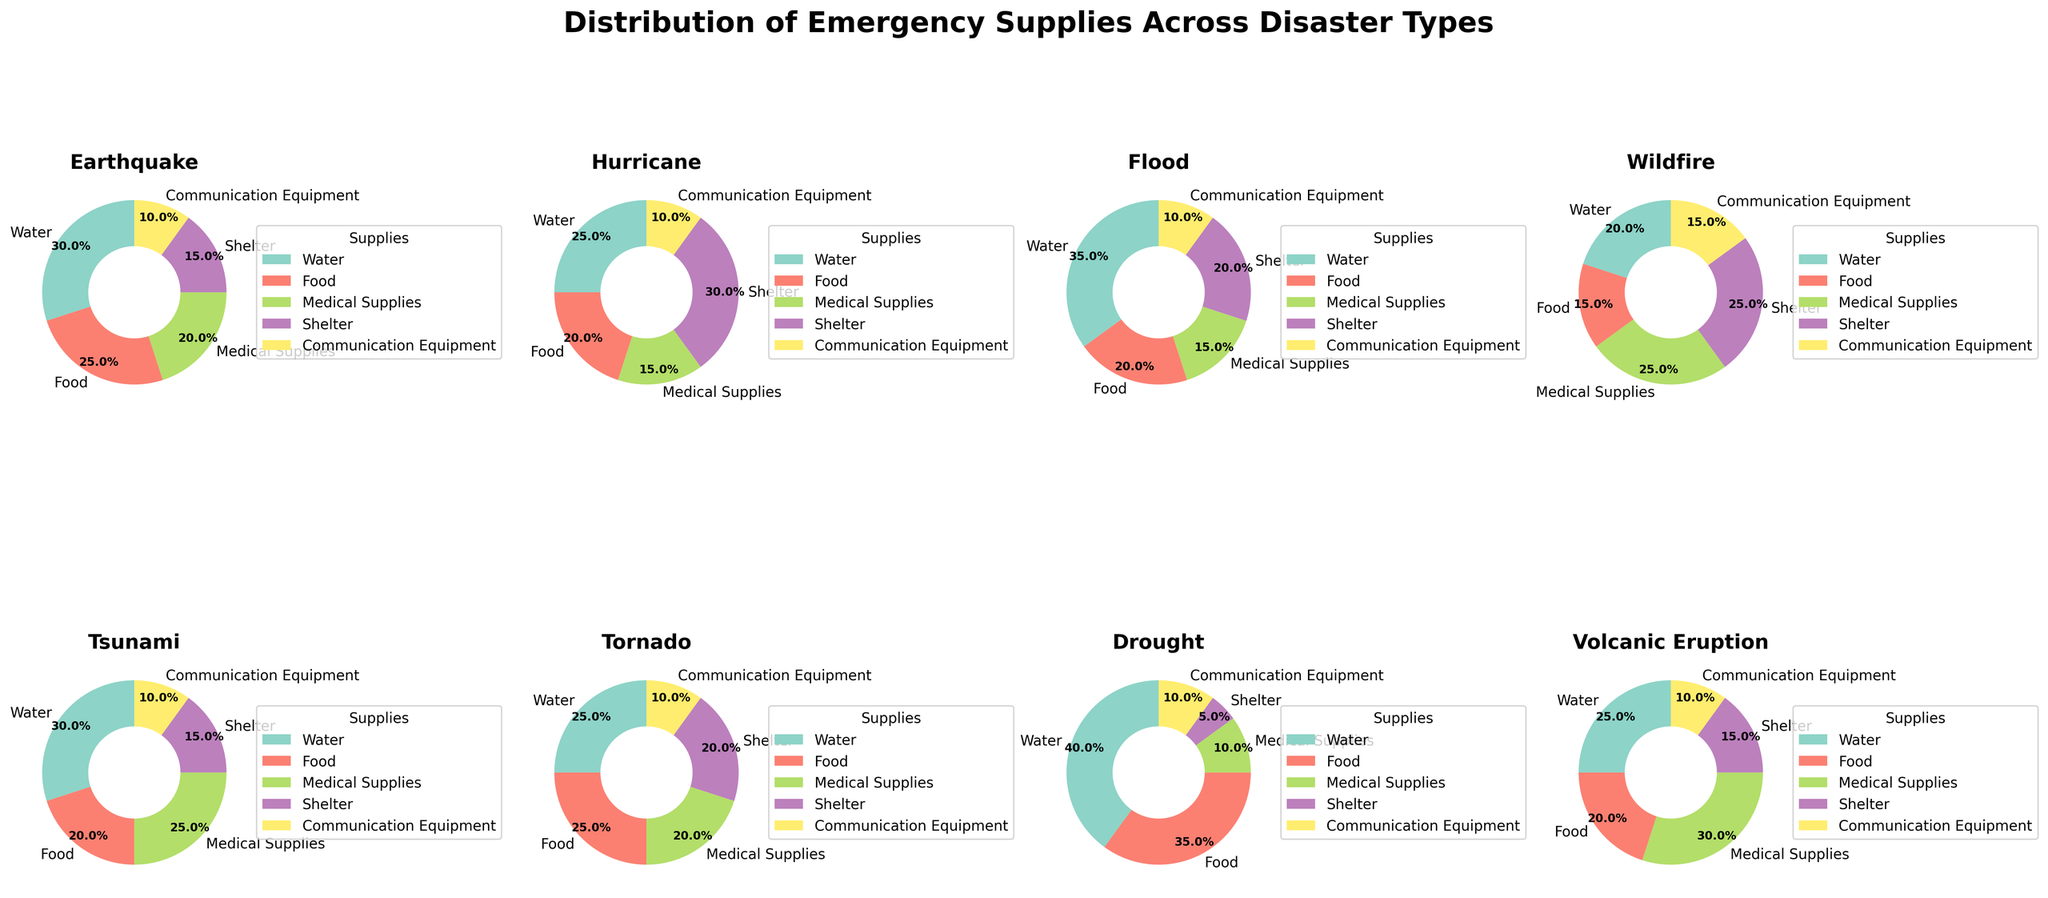What is the title of the figure? The title should be displayed at the top of the figure. Upon closer observation, it reads 'Distribution of Emergency Supplies Across Disaster Types'.
Answer: Distribution of Emergency Supplies Across Disaster Types How many subplots are there in the figure? The figure consists of a grid of small pie charts, separated into rows and columns. Counting them reveals that there are a total of 8 subplots.
Answer: 8 Which disaster type has the highest percentage of water supplies? Inspecting each pie chart, we observe that the Drought pie chart has the largest segment for water supplies, which accounts for 40%.
Answer: Drought For which disaster types does the percentage of medical supplies reach 30%? We can identify the disaster types by observing the segments in the pie charts corresponding to 'Medical Supplies'. Volcanic Eruption is the only disaster type with 30% medical supplies.
Answer: Volcanic Eruption What is the percentage of food supplies for the Hurricane disaster? Reading the pie chart labeled 'Hurricane' shows that the food supply segment is 20%.
Answer: 20% Combine the percentages of medical supplies for Earthquake and Wildfire, what is the sum? From the pie charts, Earthquake has 20% medical supplies and Wildfire has 25%. Adding them together gives 20% + 25% = 45%.
Answer: 45% Between Earthquake and Tornado, which one has more percentage of shelter supplies? In the pie charts, Earthquake has 15% for shelter, while Tornado has 20% for shelter. Therefore, Tornado has a greater percentage for shelter supplies.
Answer: Tornado Which category remains constant across all disaster types? Looking at the pie charts, 'Communication Equipment' consistently appears with the same percentage. All disaster types show 10% for communication equipment.
Answer: Communication Equipment 